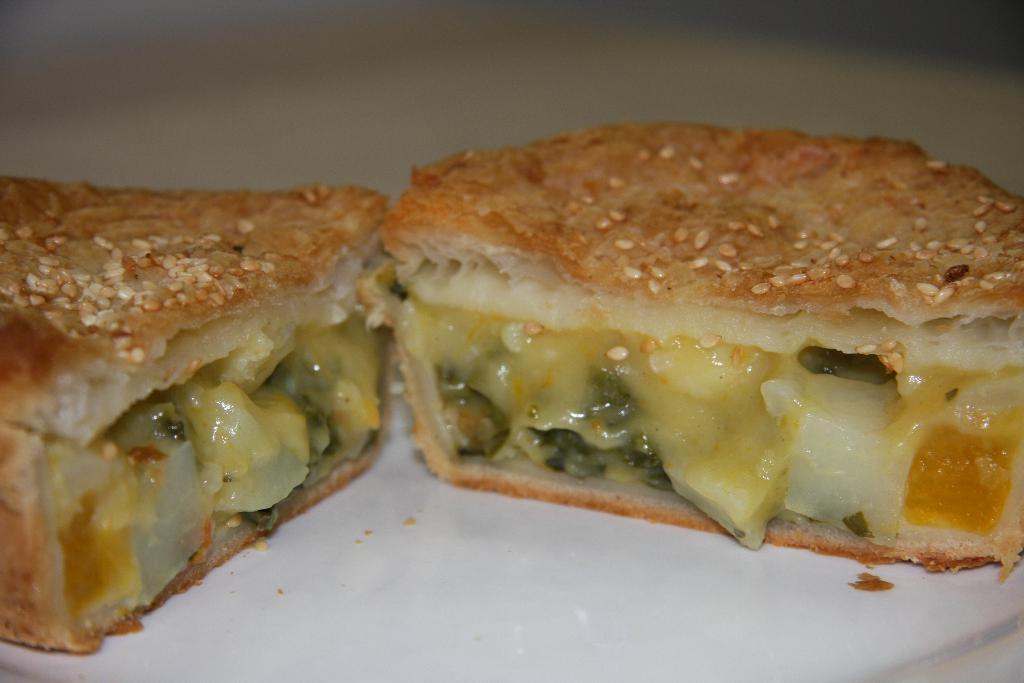Can you describe this image briefly? In the image there is a veg sandwich slice on a table. 